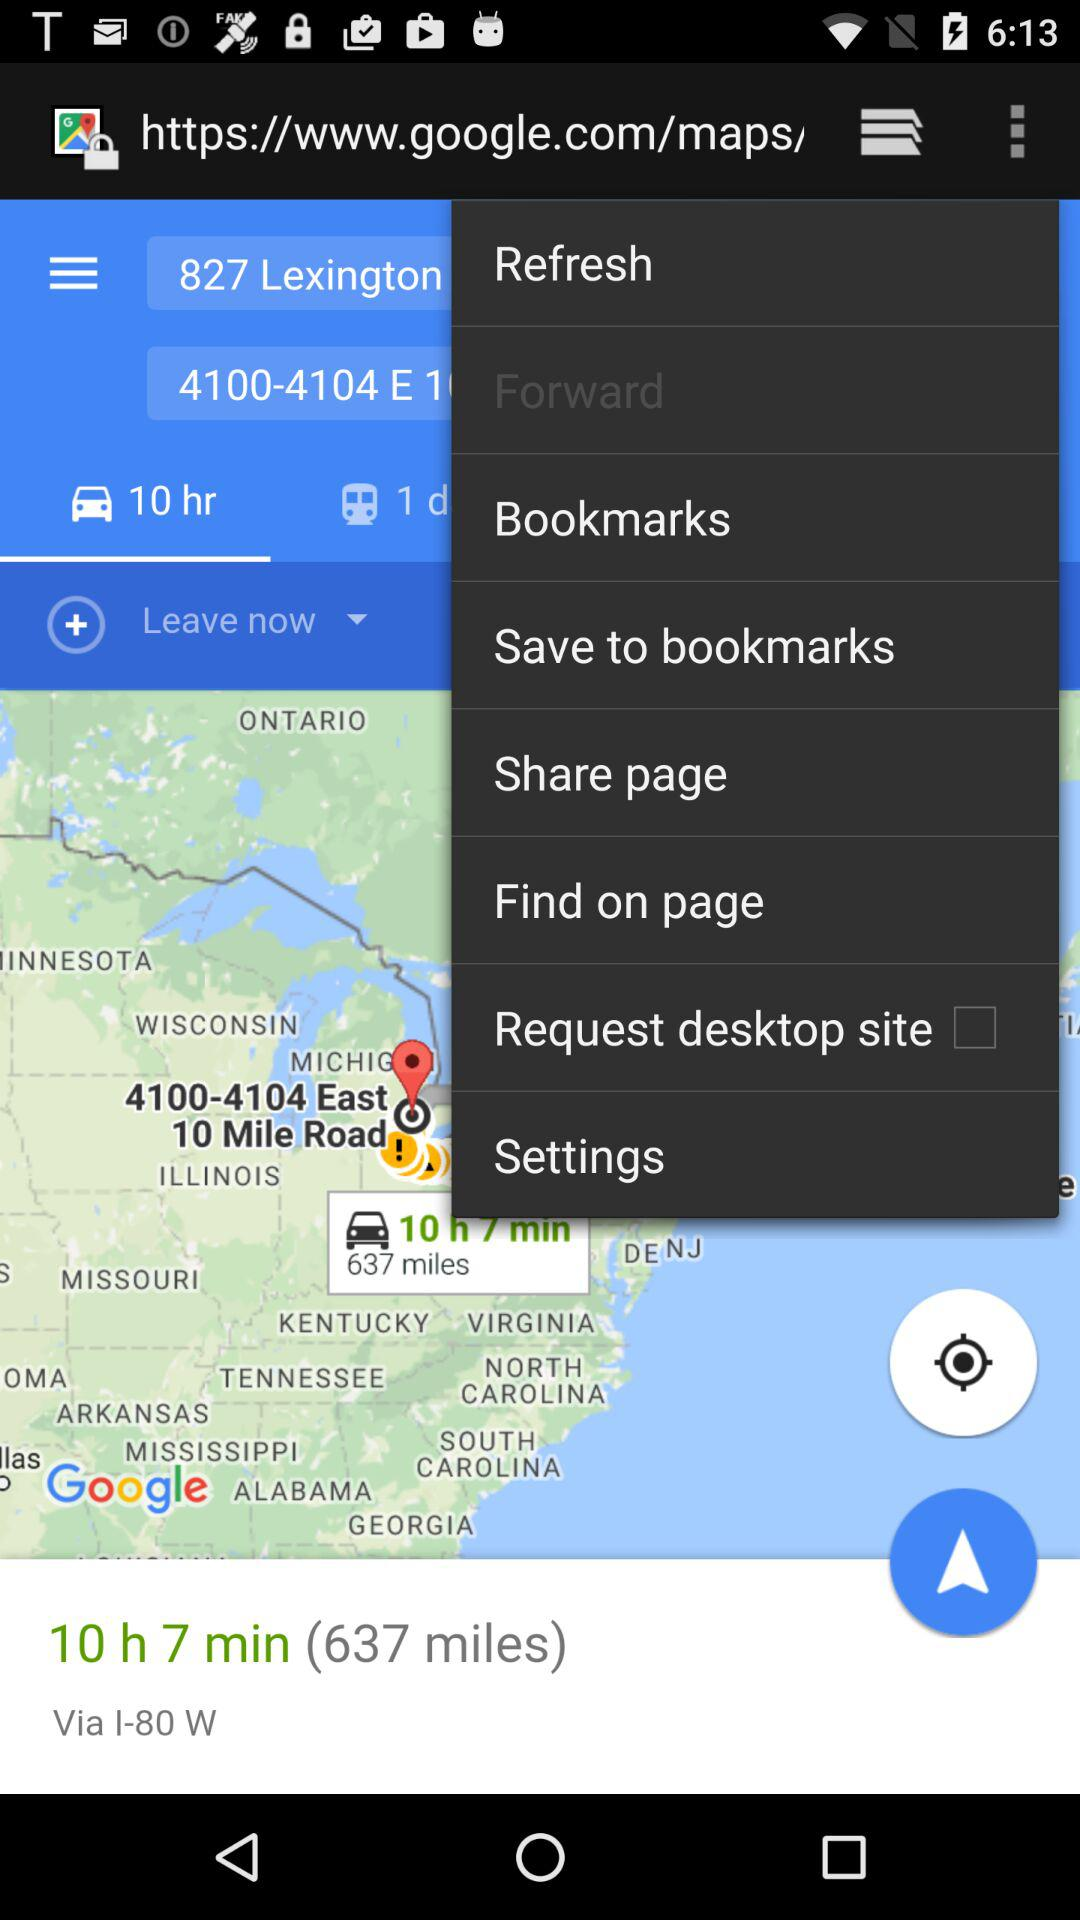What distance will be covered if travelling via the I-80W highway? The distance covered if travelling via the I-80W highway is 637 miles. 